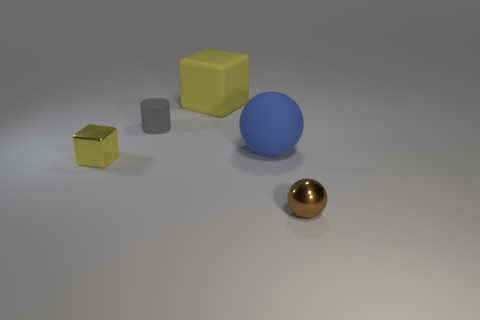What seems to be the texture of the objects? The large blue sphere has a matte texture, while the golden sphere appears to have a reflective, glossy surface. The two cubes also have a matte finish, with the yellow one larger and more brightly colored than the smaller gray one. 